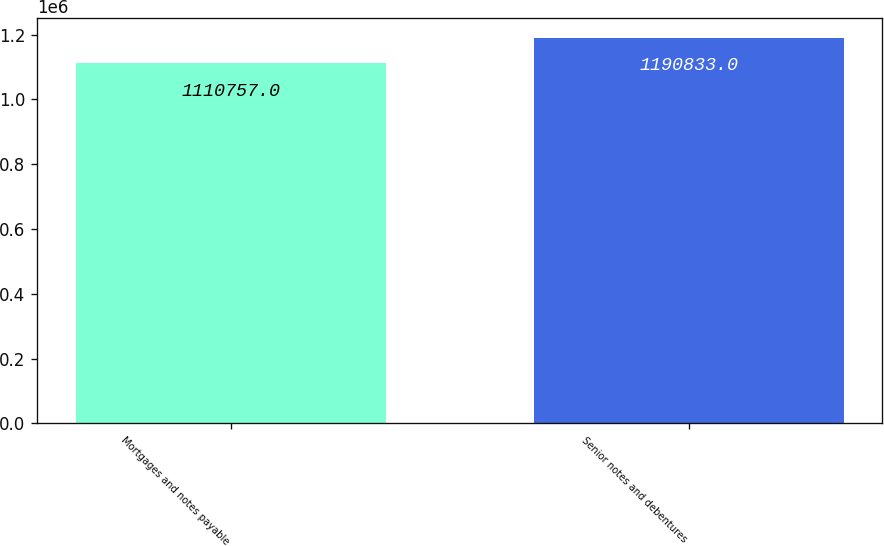Convert chart to OTSL. <chart><loc_0><loc_0><loc_500><loc_500><bar_chart><fcel>Mortgages and notes payable<fcel>Senior notes and debentures<nl><fcel>1.11076e+06<fcel>1.19083e+06<nl></chart> 